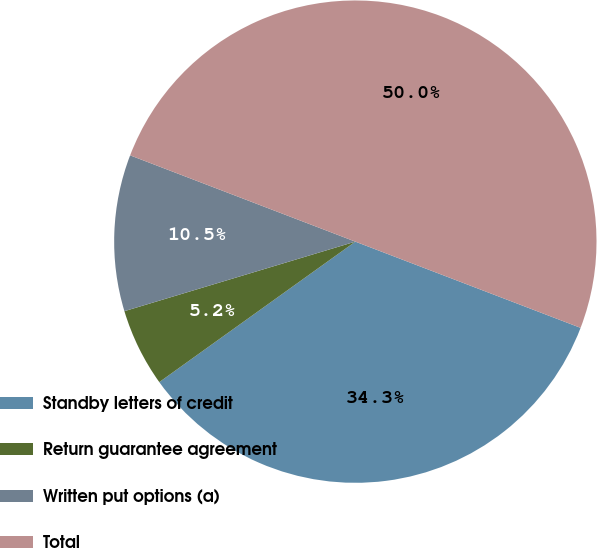Convert chart. <chart><loc_0><loc_0><loc_500><loc_500><pie_chart><fcel>Standby letters of credit<fcel>Return guarantee agreement<fcel>Written put options (a)<fcel>Total<nl><fcel>34.29%<fcel>5.24%<fcel>10.48%<fcel>50.0%<nl></chart> 